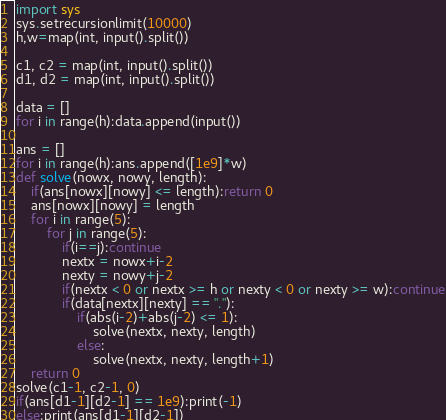<code> <loc_0><loc_0><loc_500><loc_500><_Python_>import sys
sys.setrecursionlimit(10000)
h,w=map(int, input().split())

c1, c2 = map(int, input().split())
d1, d2 = map(int, input().split())

data = []
for i in range(h):data.append(input())

ans = []
for i in range(h):ans.append([1e9]*w)
def solve(nowx, nowy, length):
    if(ans[nowx][nowy] <= length):return 0
    ans[nowx][nowy] = length
    for i in range(5):
        for j in range(5):
            if(i==j):continue
            nextx = nowx+i-2
            nexty = nowy+j-2
            if(nextx < 0 or nextx >= h or nexty < 0 or nexty >= w):continue
            if(data[nextx][nexty] == "."):
                if(abs(i-2)+abs(j-2) <= 1):
                    solve(nextx, nexty, length)
                else:
                    solve(nextx, nexty, length+1)
    return 0
solve(c1-1, c2-1, 0)
if(ans[d1-1][d2-1] == 1e9):print(-1)
else:print(ans[d1-1][d2-1])</code> 